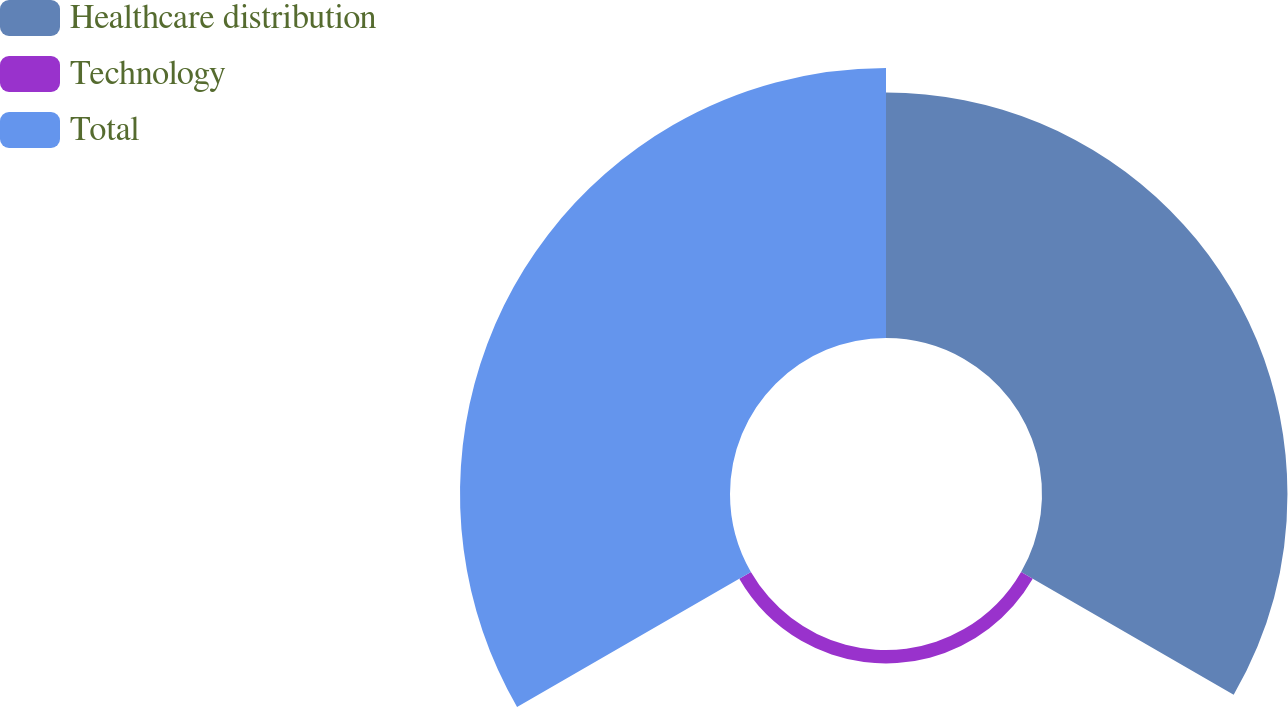Convert chart. <chart><loc_0><loc_0><loc_500><loc_500><pie_chart><fcel>Healthcare distribution<fcel>Technology<fcel>Total<nl><fcel>46.41%<fcel>2.54%<fcel>51.05%<nl></chart> 